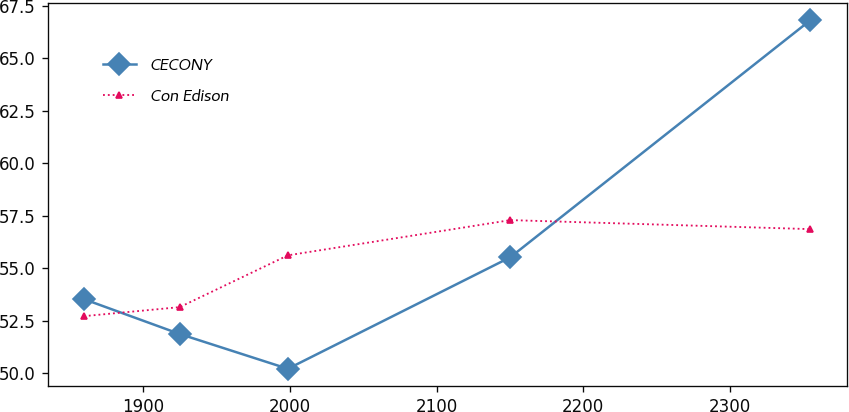Convert chart. <chart><loc_0><loc_0><loc_500><loc_500><line_chart><ecel><fcel>CECONY<fcel>Con Edison<nl><fcel>1859.82<fcel>53.52<fcel>52.71<nl><fcel>1925.02<fcel>51.86<fcel>53.14<nl><fcel>1998.73<fcel>50.2<fcel>55.61<nl><fcel>2150.31<fcel>55.52<fcel>57.29<nl><fcel>2354.66<fcel>66.82<fcel>56.86<nl></chart> 